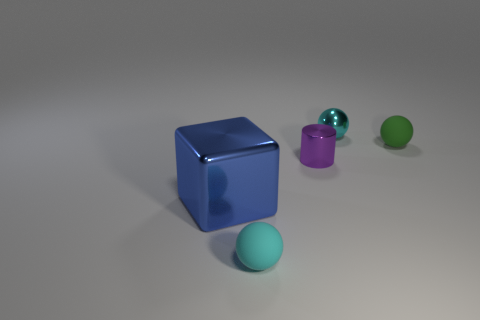Is there anything else that has the same size as the block?
Ensure brevity in your answer.  No. Is the purple metallic cylinder the same size as the metal sphere?
Make the answer very short. Yes. There is a metal object left of the small cyan sphere that is in front of the tiny cyan metal thing; is there a object behind it?
Keep it short and to the point. Yes. There is a small green thing that is the same shape as the cyan matte thing; what is it made of?
Give a very brief answer. Rubber. What is the color of the matte thing that is left of the purple metallic cylinder?
Make the answer very short. Cyan. What size is the blue metallic block?
Provide a succinct answer. Large. There is a green matte sphere; is it the same size as the matte thing that is to the left of the tiny metallic cylinder?
Make the answer very short. Yes. There is a small rubber thing that is left of the small green sphere that is behind the cyan sphere that is in front of the cyan metal thing; what color is it?
Give a very brief answer. Cyan. Is the tiny object that is behind the green matte object made of the same material as the green sphere?
Your answer should be very brief. No. What number of other things are there of the same material as the blue object
Your answer should be compact. 2. 